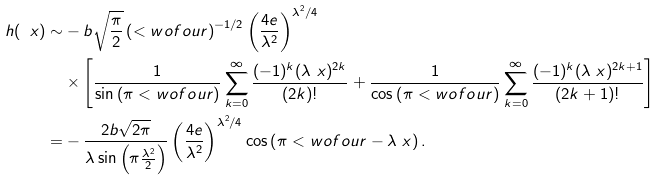Convert formula to latex. <formula><loc_0><loc_0><loc_500><loc_500>h ( \ x ) \sim & - b \sqrt { \frac { \pi } { 2 } } \left ( < w o f o u r \right ) ^ { - 1 / 2 } \left ( \frac { 4 e } { \lambda ^ { 2 } } \right ) ^ { \lambda ^ { 2 } / 4 } \\ & \times \left [ \frac { 1 } { \sin \left ( \pi < w o f o u r \right ) } \sum _ { k = 0 } ^ { \infty } \frac { ( - 1 ) ^ { k } ( \lambda \ x ) ^ { 2 k } } { ( 2 k ) ! } + \frac { 1 } { \cos \left ( \pi < w o f o u r \right ) } \sum _ { k = 0 } ^ { \infty } \frac { ( - 1 ) ^ { k } ( \lambda \ x ) ^ { 2 k + 1 } } { ( 2 k + 1 ) ! } \right ] \\ = & - \frac { 2 b \sqrt { 2 \pi } } { \lambda \sin \left ( \pi \frac { \lambda ^ { 2 } } { 2 } \right ) } \left ( \frac { 4 e } { \lambda ^ { 2 } } \right ) ^ { \lambda ^ { 2 } / 4 } \cos \left ( \pi < w o f o u r - \lambda \ x \right ) .</formula> 